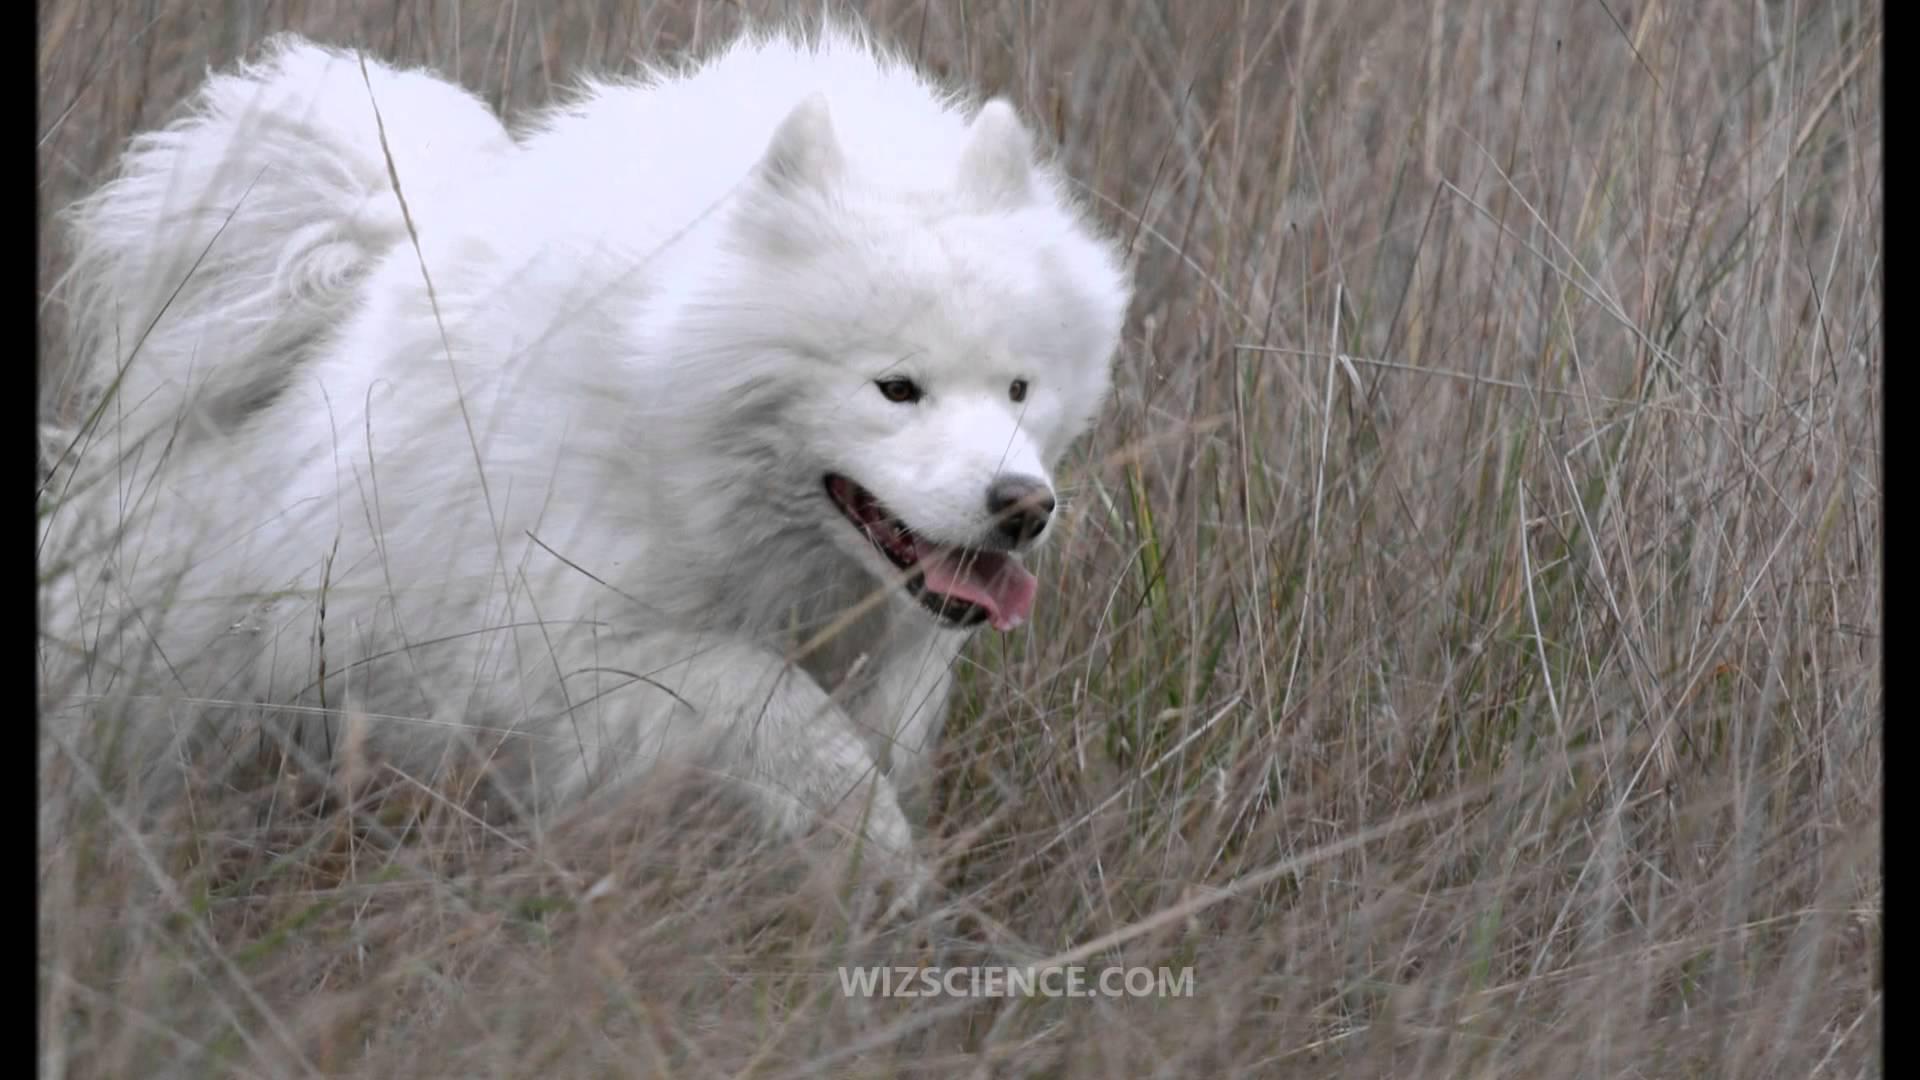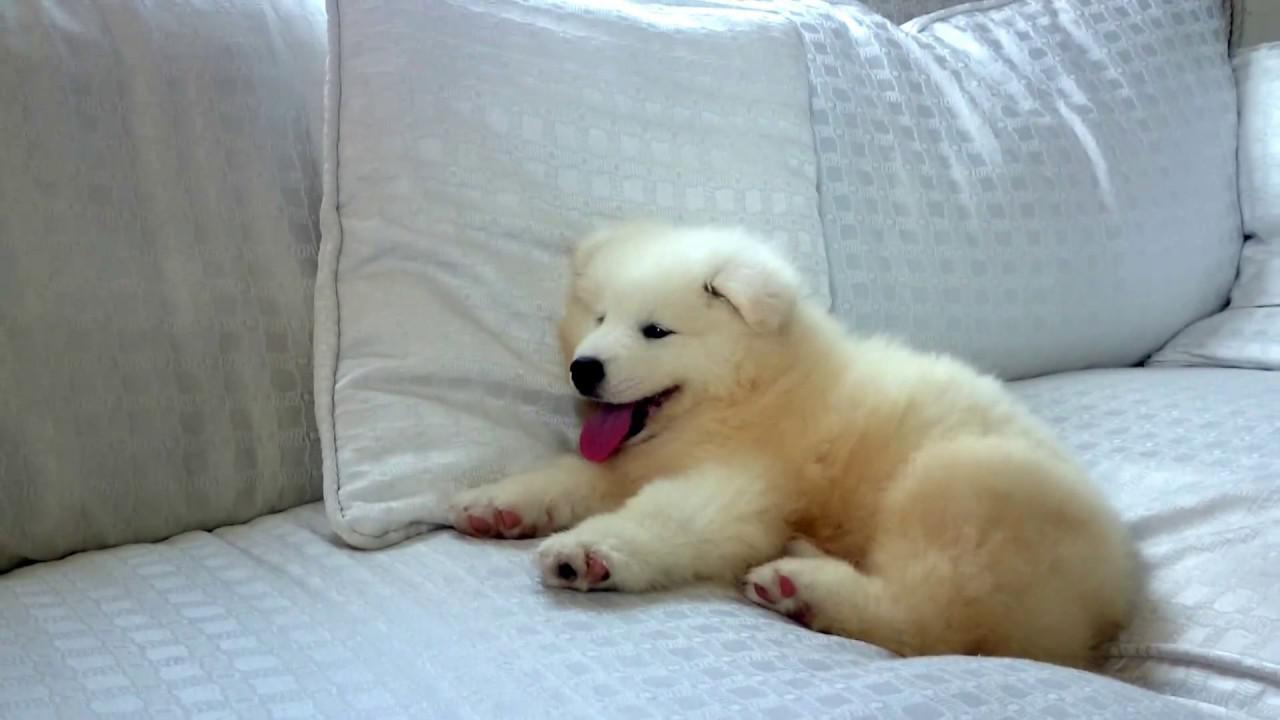The first image is the image on the left, the second image is the image on the right. Assess this claim about the two images: "At least one dog in one of the images has its tongue hanging out.". Correct or not? Answer yes or no. Yes. The first image is the image on the left, the second image is the image on the right. Evaluate the accuracy of this statement regarding the images: "Right image shows a white dog sleeping on the floor with its belly facing up.". Is it true? Answer yes or no. No. 